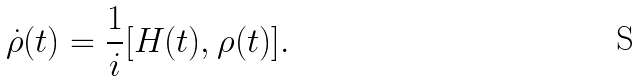Convert formula to latex. <formula><loc_0><loc_0><loc_500><loc_500>\dot { \rho } ( t ) = \frac { 1 } { i } [ H ( t ) , \rho ( t ) ] .</formula> 